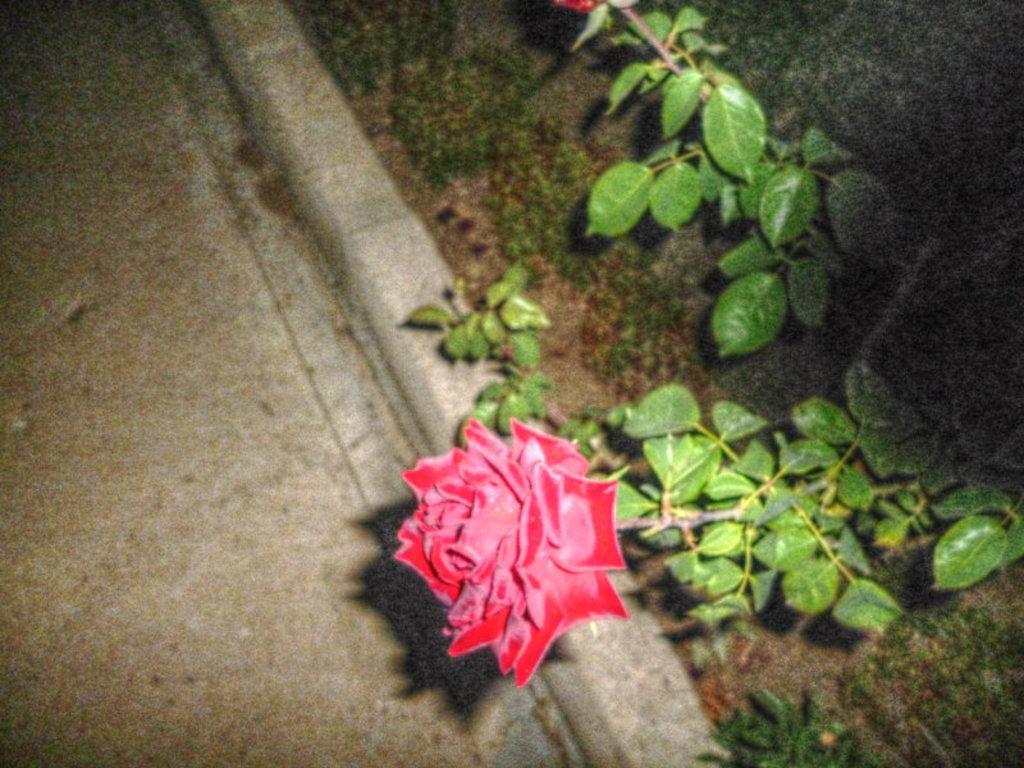Describe this image in one or two sentences. In this picture we can see a flower with plant on the ground. 